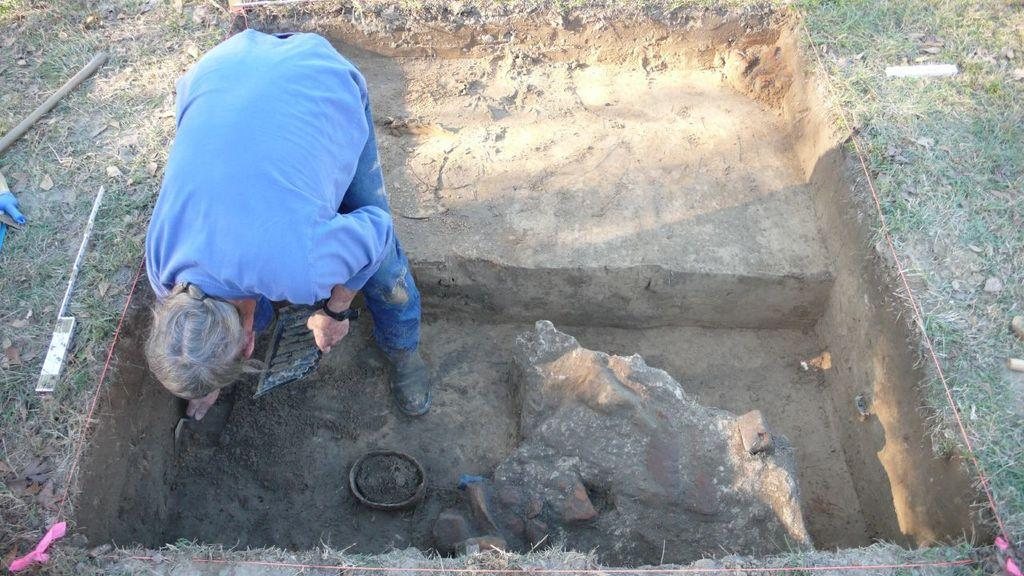What is the person in the image doing? The person is standing on the ground and holding a tool and a tray. What type of surface is visible in the image? There is grass visible in the image. What other items can be seen in the image besides the person? There are tools, a stick, a bowl of mud, a rock, and a thread present in the image. What type of gun is the person holding in the image? There is no gun present in the image; the person is holding a tool and a tray. What is the person's chin doing in the image? The person's chin is not mentioned in the image, as the focus is on their actions and the objects they are holding. 